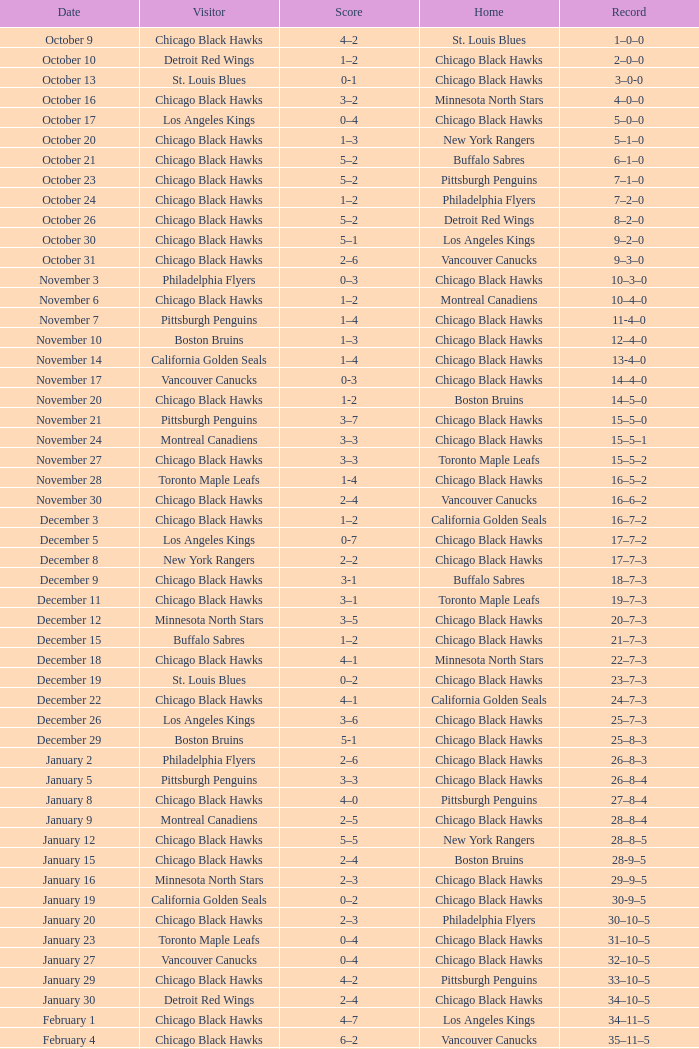Can you provide the score from the november 17th home game between the chicago black hawks and the vancouver canucks? 0-3. 